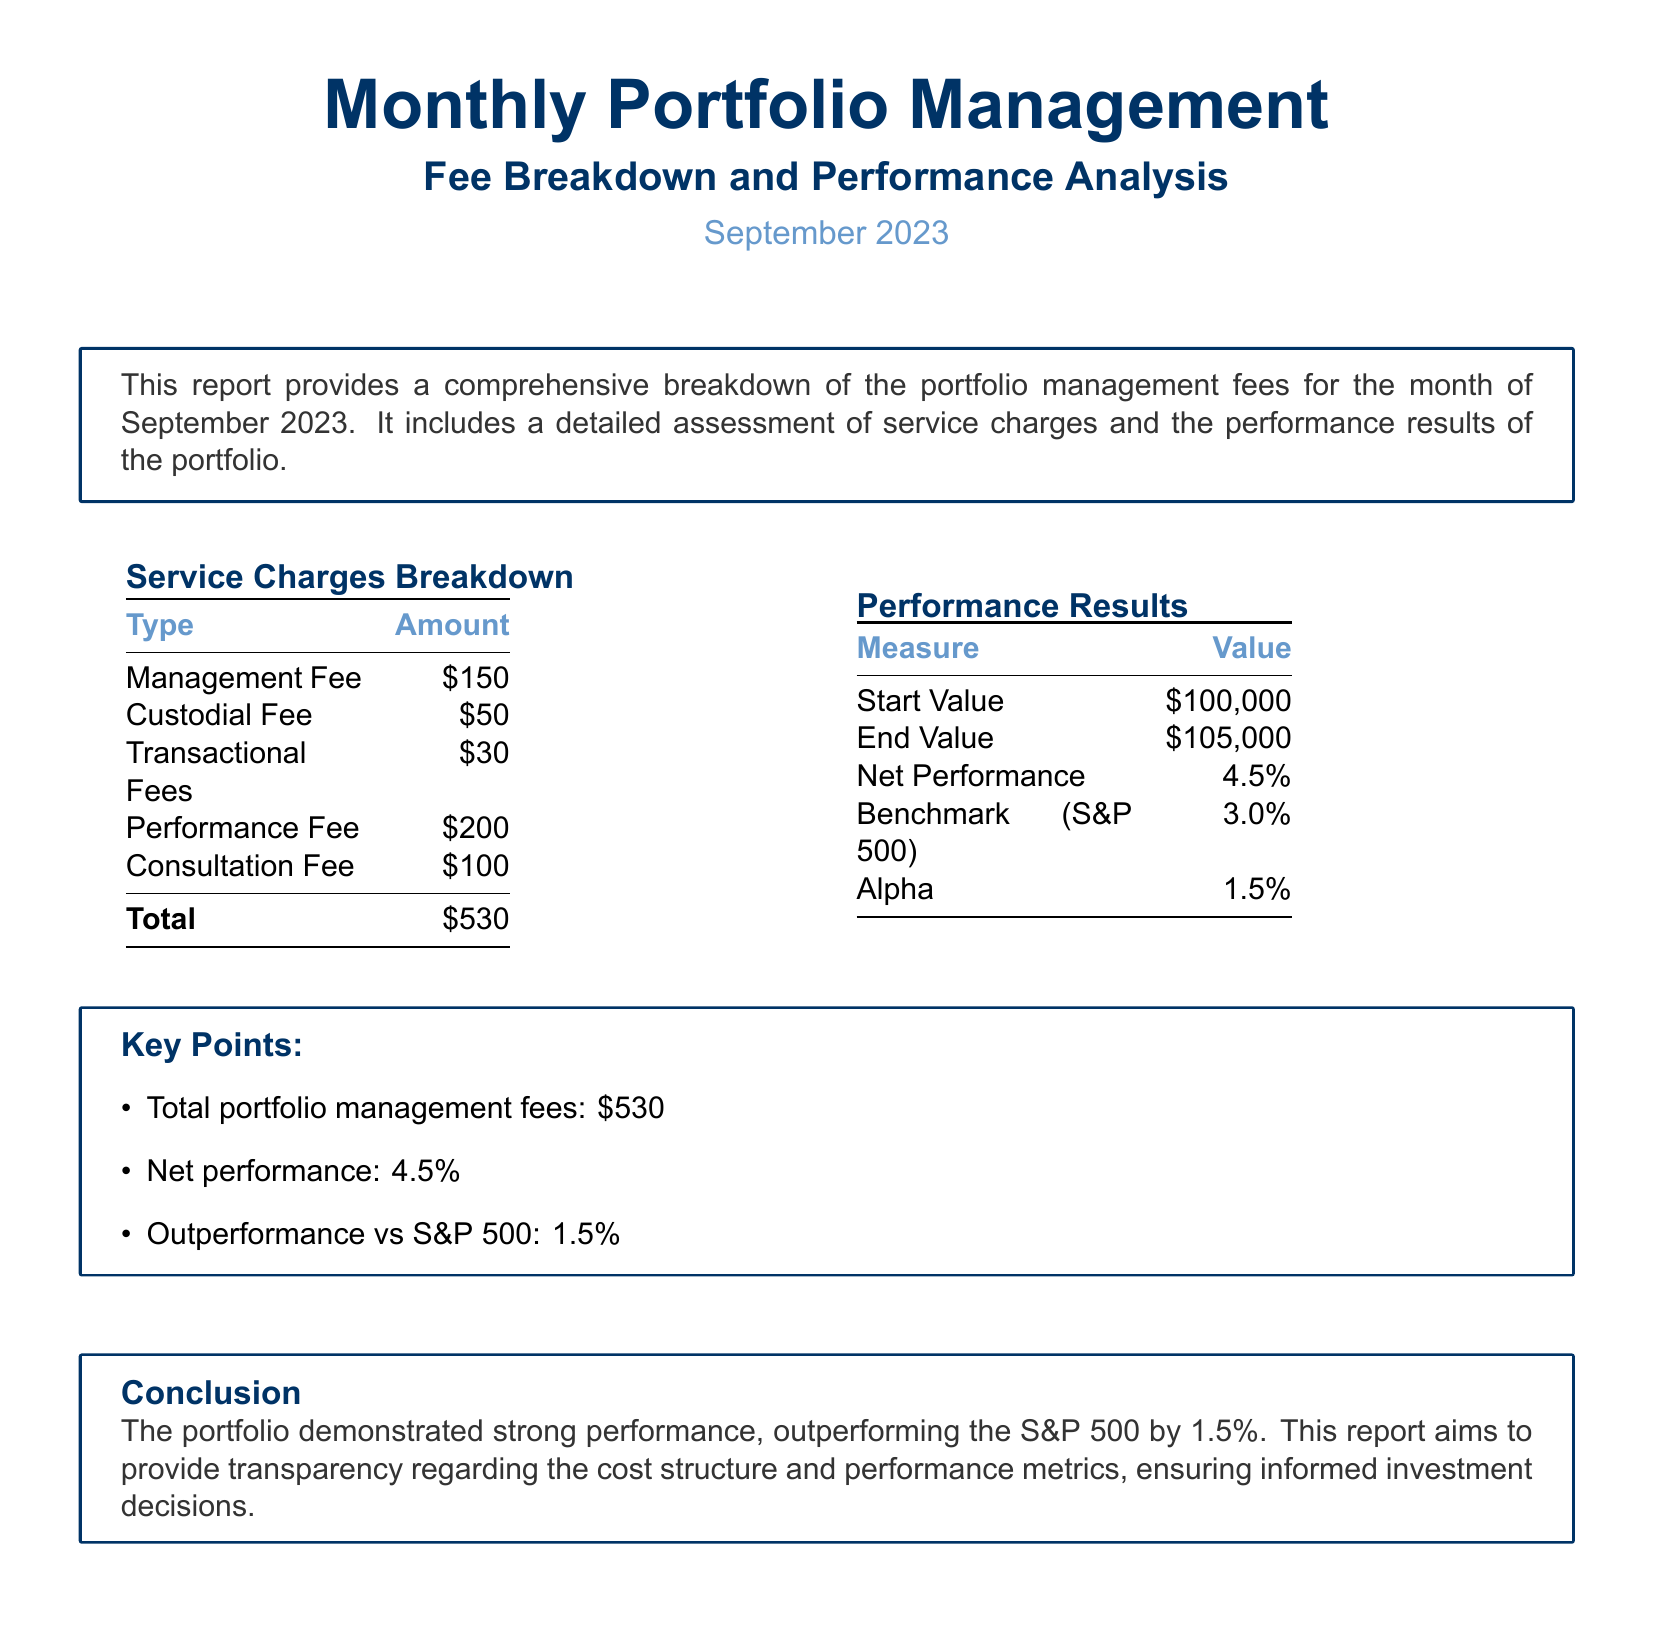what is the total amount of service charges? The total amount of service charges is the sum of all the individual service charges listed in the document.
Answer: $530 what is the performance fee? The performance fee is listed as one of the service charges in the document.
Answer: $200 what was the starting value of the portfolio? The starting value is explicitly mentioned in the performance results section of the document.
Answer: $100,000 what is the net performance percentage for the month? The net performance percentage is stated directly in the performance results section of the document.
Answer: 4.5% how much did the portfolio outperform the S&P 500? The outperformance is calculated by comparing the net performance of the portfolio to the benchmark S&P 500 performance provided.
Answer: 1.5% what is the custodial fee charged? The custodial fee is listed among the other service charges in the document.
Answer: $50 what was the end value of the portfolio? The end value represents the final position of the portfolio at the conclusion of the reporting period, as presented in the document.
Answer: $105,000 what are the key points summarized in the document? The key points provide a quick overview of the total fees, net performance, and outperformance information succinctly.
Answer: Total portfolio management fees: $530; Net performance: 4.5%; Outperformance vs S&P 500: 1.5% what does the conclusion emphasize? The conclusion summarizes the portfolio's performance, highlighting its outperformance and the transparency of fees, which is crucial for understanding investment outcomes.
Answer: Strong performance, outperforming the S&P 500 by 1.5% 